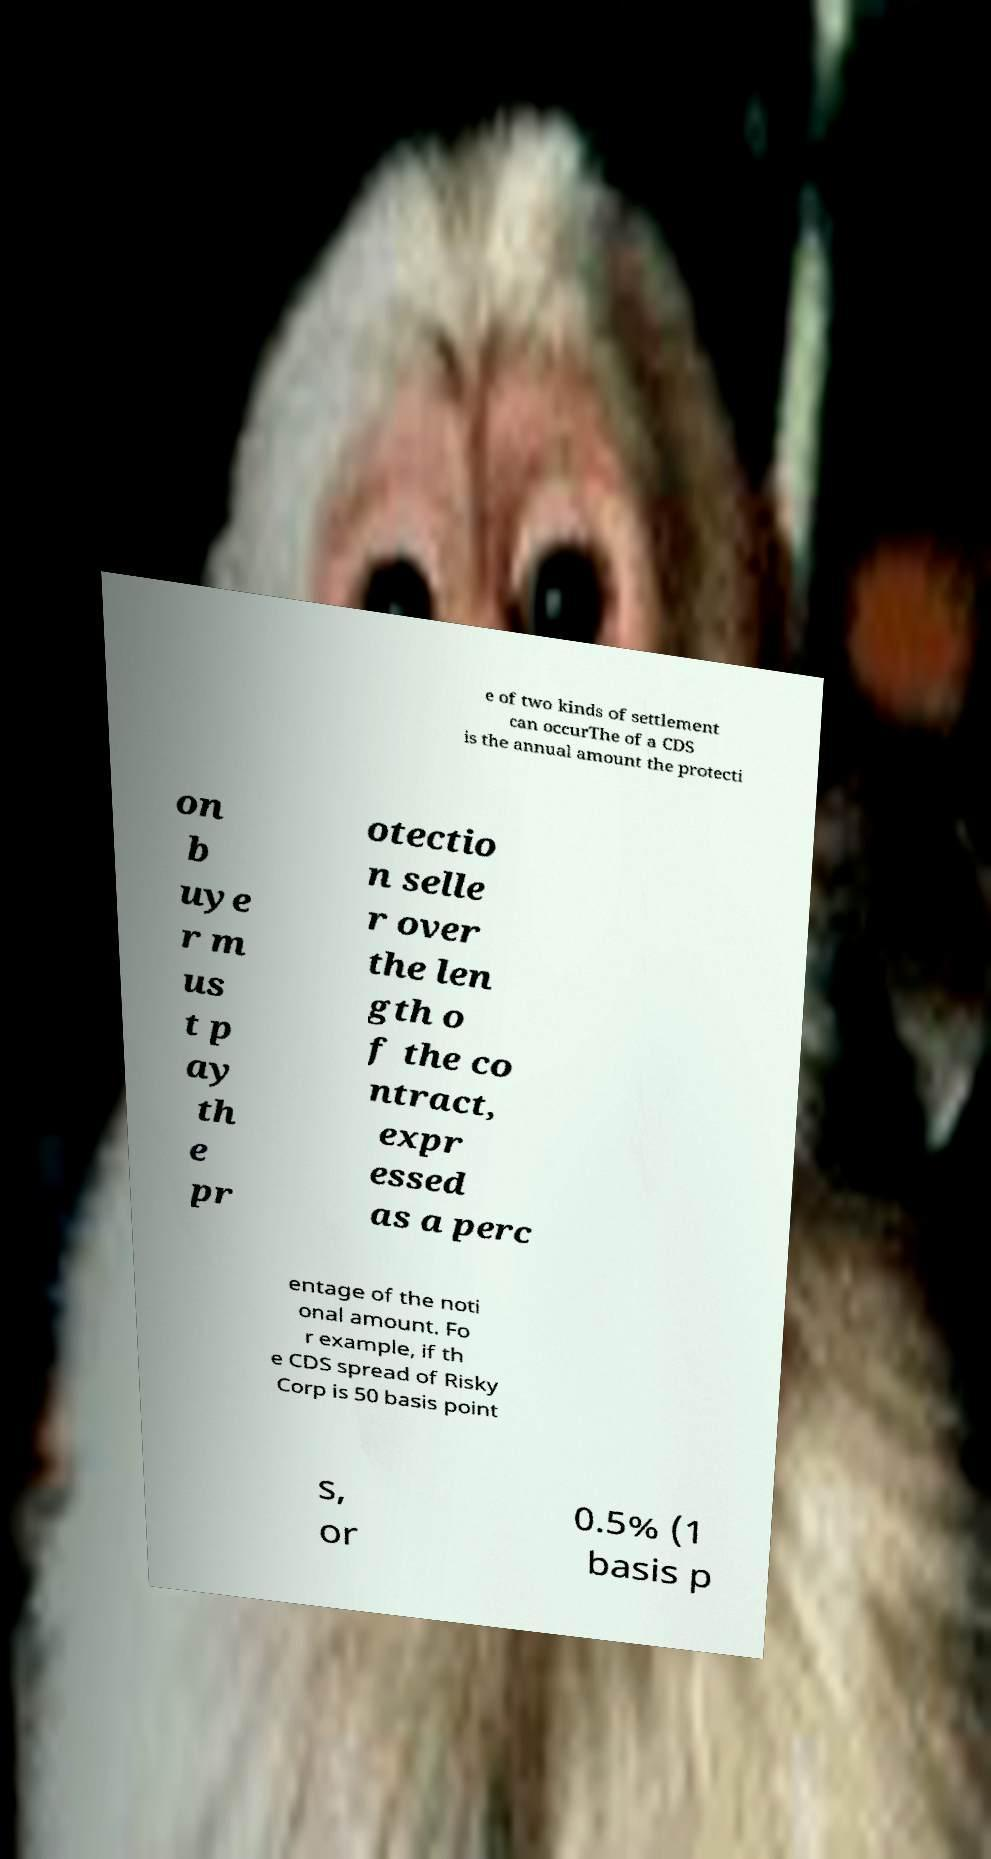Can you accurately transcribe the text from the provided image for me? e of two kinds of settlement can occurThe of a CDS is the annual amount the protecti on b uye r m us t p ay th e pr otectio n selle r over the len gth o f the co ntract, expr essed as a perc entage of the noti onal amount. Fo r example, if th e CDS spread of Risky Corp is 50 basis point s, or 0.5% (1 basis p 